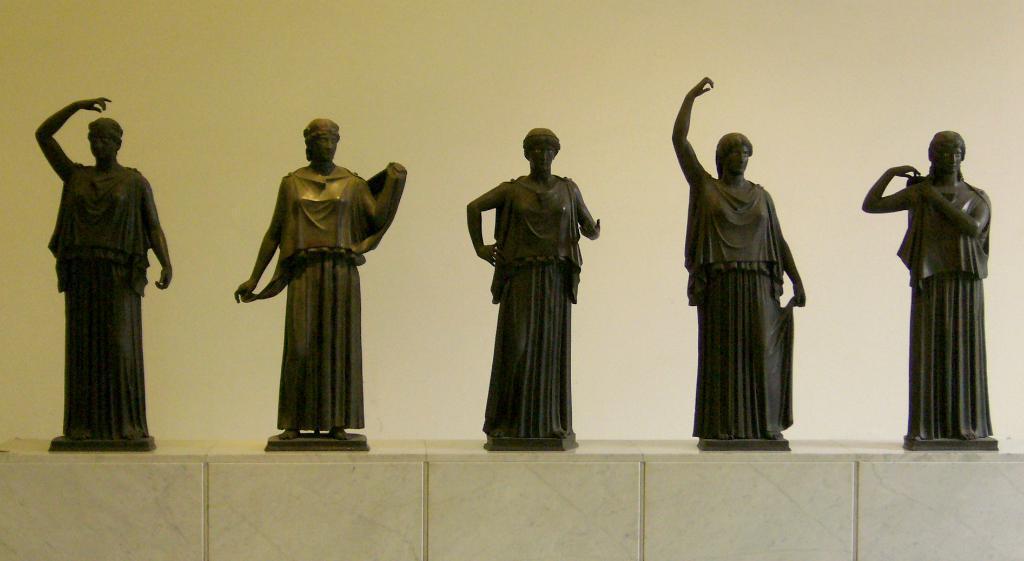Could you give a brief overview of what you see in this image? We can see sculptures on the surface,behind these sculptures we can see wall. 